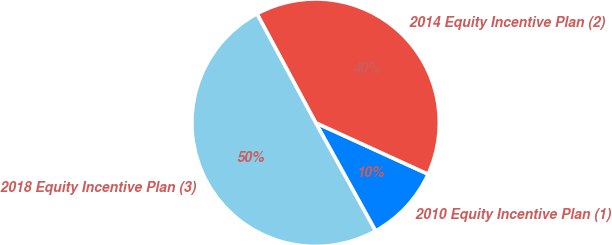Convert chart to OTSL. <chart><loc_0><loc_0><loc_500><loc_500><pie_chart><fcel>2010 Equity Incentive Plan (1)<fcel>2014 Equity Incentive Plan (2)<fcel>2018 Equity Incentive Plan (3)<nl><fcel>10.12%<fcel>39.69%<fcel>50.19%<nl></chart> 